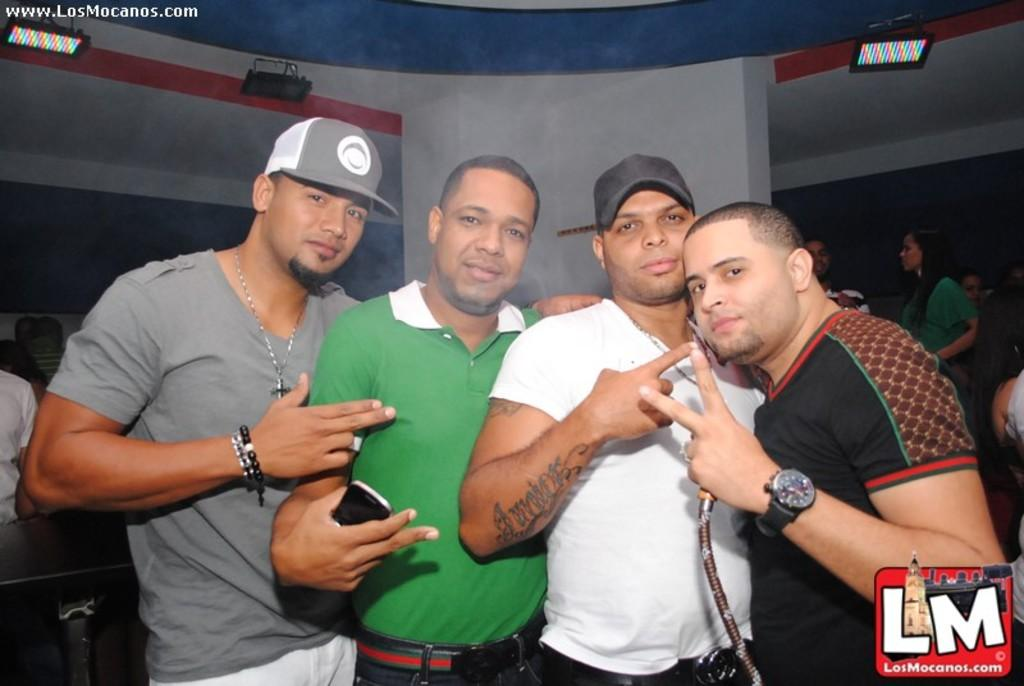How many people are present in the image? There are four people in the image. What are two of the people wearing? Two of the people are wearing caps. What is one person doing with their hand in the image? One person is holding a phone. Can you describe the background of the image? There are other people visible in the background. What is on the roof in the image? There are lights on the roof. What type of liquid can be seen flowing from the person's mouth in the image? There is no liquid flowing from anyone's mouth in the image. What fact about the image can be determined from the given facts? The given facts do not provide any additional facts beyond what is already mentioned in the conversation. 